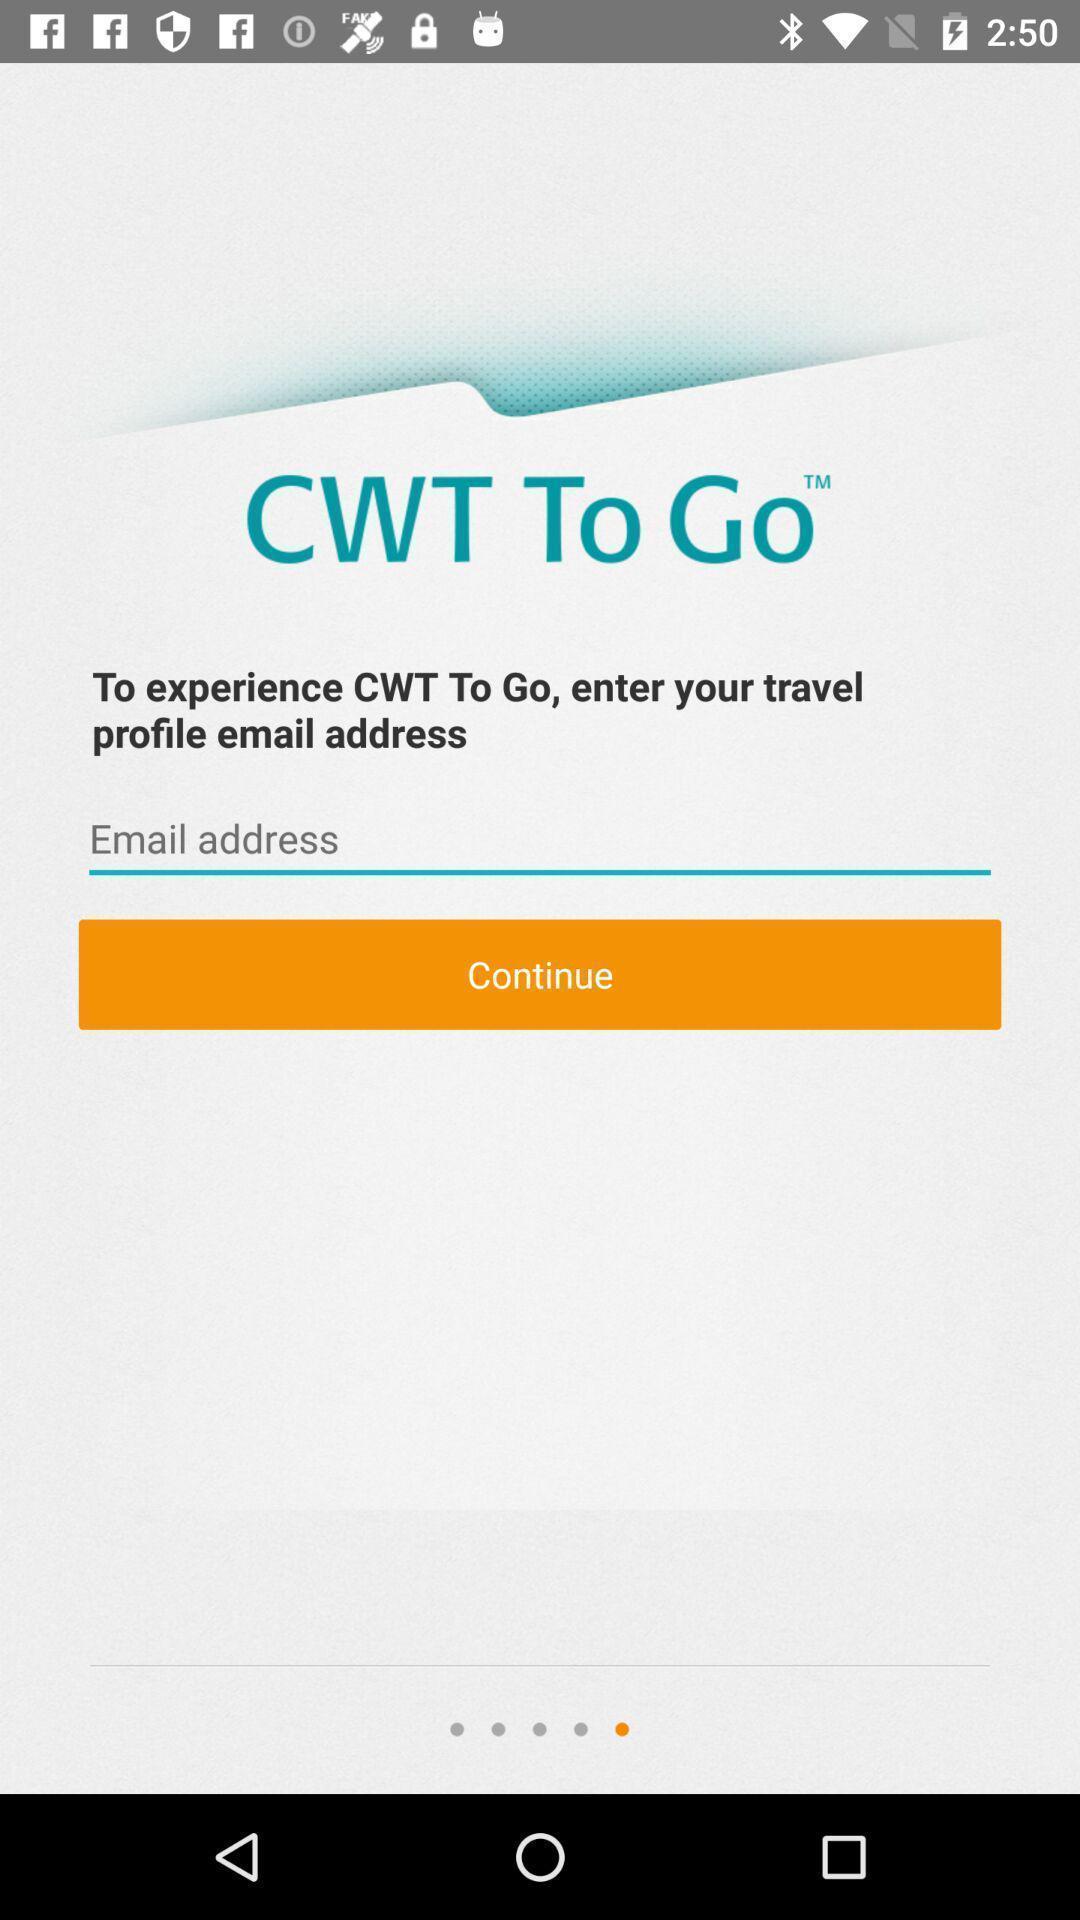Describe this image in words. Window displaying a flight app. 